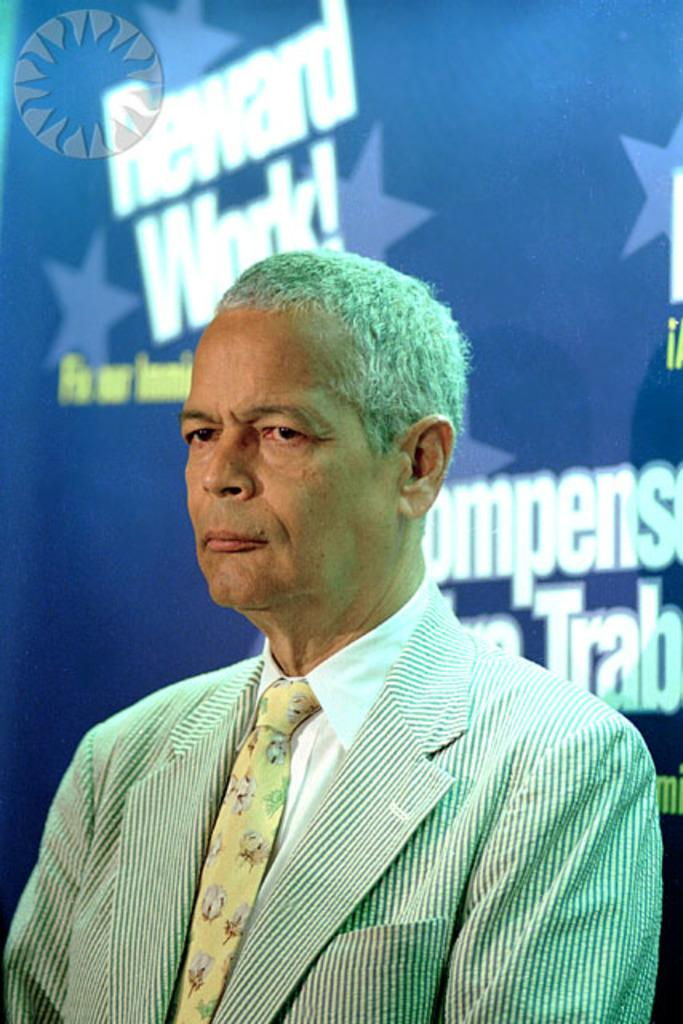Who is present in the image? There is a man in the image. What is the man wearing on his upper body? The man is wearing a coat, a shirt, and a tie. What color is the banner in the image? The banner in the image is blue. What type of soup is being served in the image? There is no soup present in the image. What kind of flower can be seen in the image? There are no flowers present in the image. 